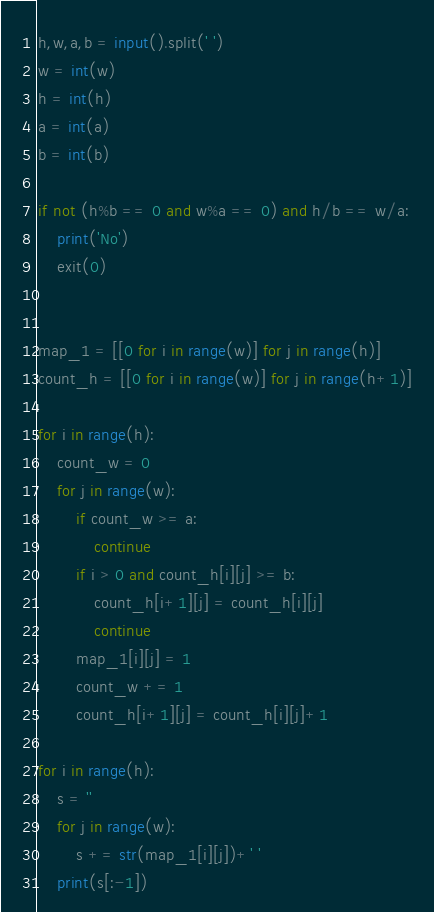<code> <loc_0><loc_0><loc_500><loc_500><_Python_>
h,w,a,b = input().split(' ')
w = int(w)
h = int(h)
a = int(a)
b = int(b)

if not (h%b == 0 and w%a == 0) and h/b == w/a:
    print('No')
    exit(0)
    

map_1 = [[0 for i in range(w)] for j in range(h)]
count_h = [[0 for i in range(w)] for j in range(h+1)]
 
for i in range(h):
    count_w = 0
    for j in range(w):
        if count_w >= a:
            continue
        if i > 0 and count_h[i][j] >= b:
            count_h[i+1][j] = count_h[i][j]
            continue
        map_1[i][j] = 1
        count_w += 1
        count_h[i+1][j] = count_h[i][j]+1
                
for i in range(h):
    s = ''
    for j in range(w):
        s += str(map_1[i][j])+' '
    print(s[:-1])</code> 